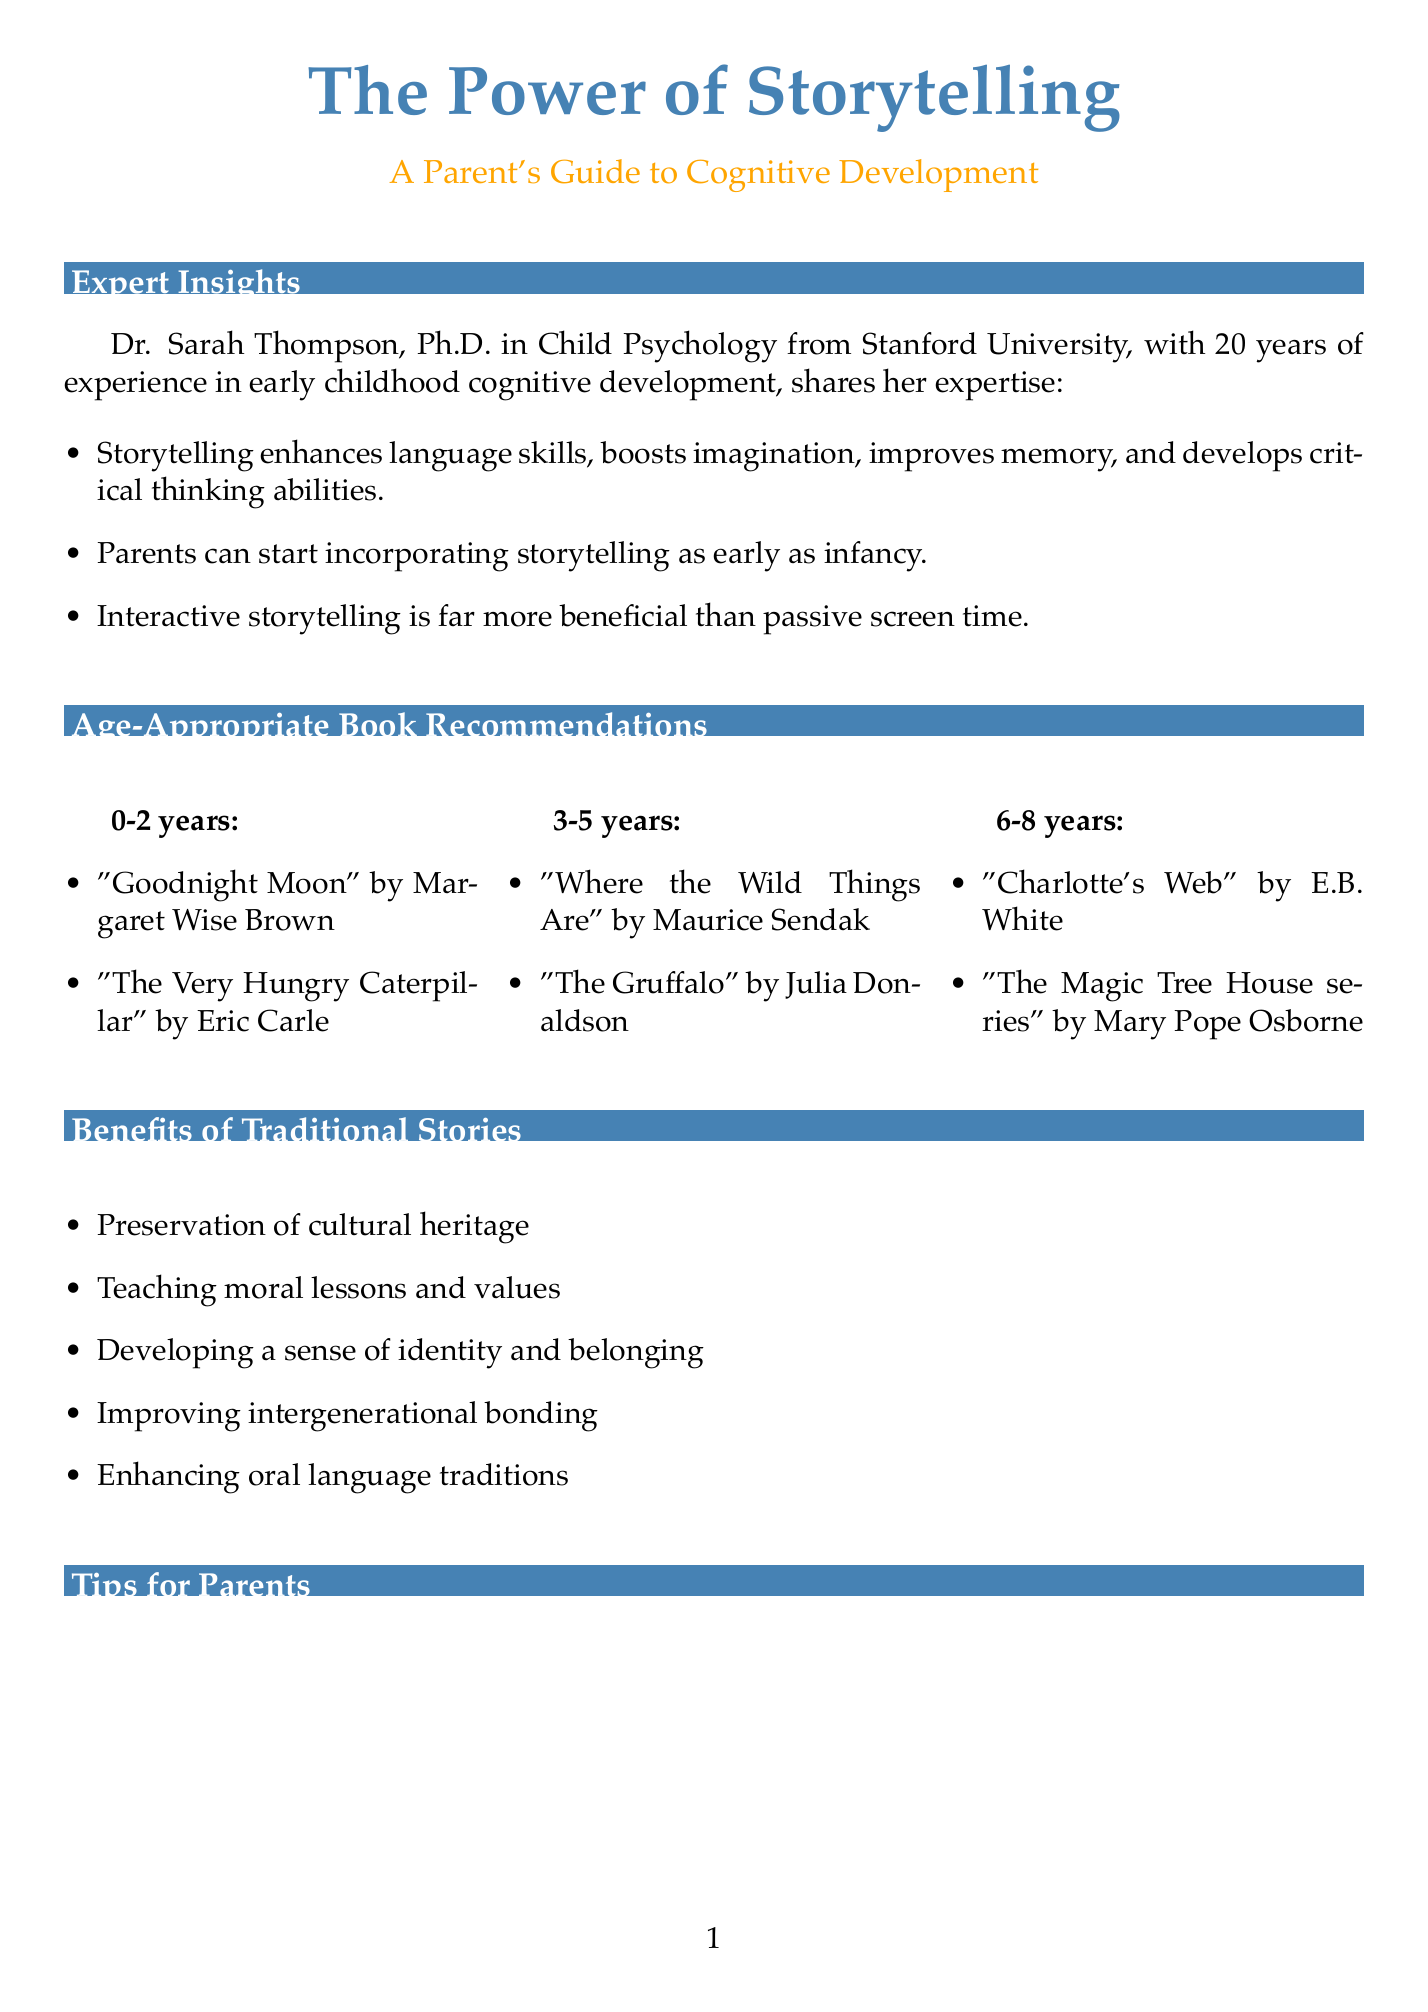What are the cognitive benefits of storytelling? The cognitive benefits of storytelling include enhanced language skills, boosted imagination, improved memory, and developed critical thinking abilities.
Answer: enhanced language skills, boosted imagination, improved memory, developed critical thinking abilities At what age can parents start storytelling? Parents can start incorporating storytelling into their child's routine as early as infancy.
Answer: infancy Who is the expert interviewed in the newsletter? The expert interviewed is Dr. Sarah Thompson.
Answer: Dr. Sarah Thompson What is a benefit of "Where the Wild Things Are"? "Where the Wild Things Are" encourages imagination and emotional regulation.
Answer: encourages imagination and emotional regulation Which research finding states a percentage increase in language comprehension skills? The University of California, Berkeley (2018) study found that children regularly read to showed 37% higher language comprehension skills by age 4 compared to those who weren't.
Answer: 37% What storytelling technique uses objects to engage senses? The use of props is the technique that incorporates simple objects to bring the story to life and engage multiple senses.
Answer: use of props What is one reason traditional stories are important? One reason is the preservation of cultural heritage.
Answer: preservation of cultural heritage How many book recommendations are provided for 3-5 years age group? There are two book recommendations provided for the 3-5 years age group.
Answer: two 